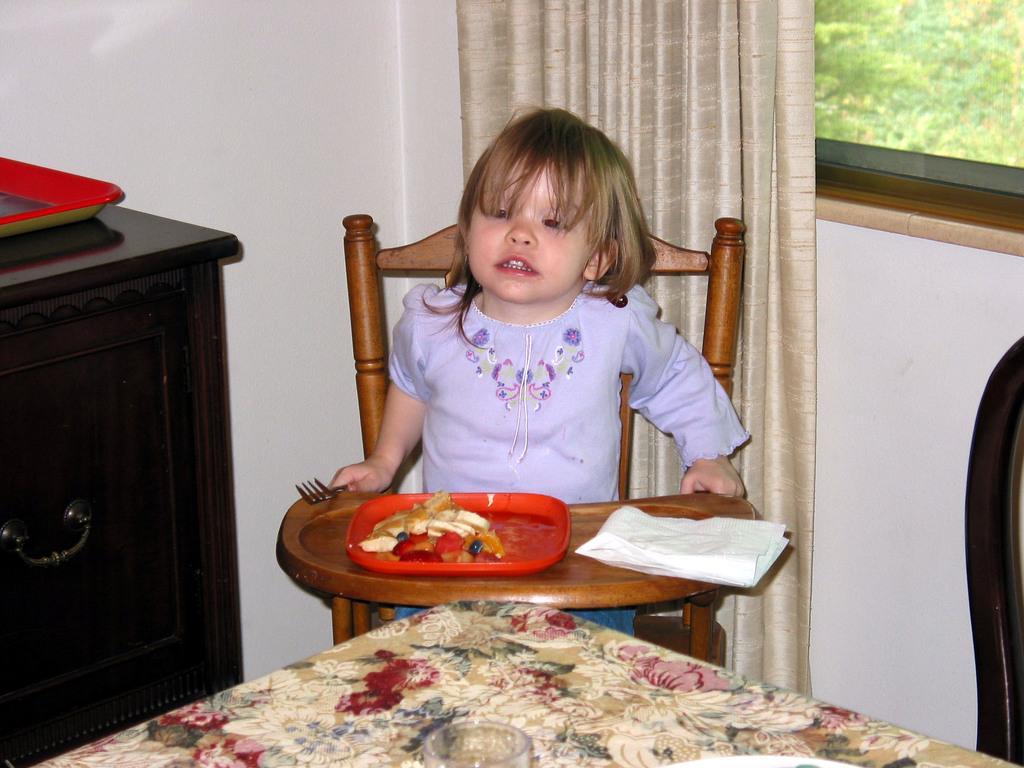Please provide a concise description of this image. In this picture there is a girl who is sitting on the chair and in front of her we can see red color plate. On the plate we can see apple, grapes, banana, oranges and other fruit pieces. Beside that we can see a tissue paper. She is holding a fork. On the table we can see water glass. On the left there is a tray on the cupboard. On the top right corner we can see trees through the window. Here we can see a window cloth. 